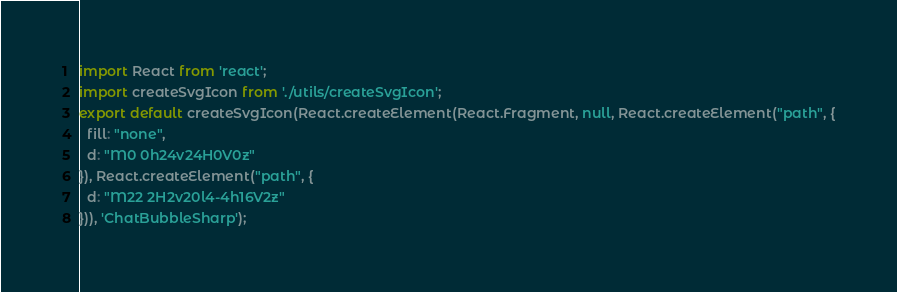<code> <loc_0><loc_0><loc_500><loc_500><_JavaScript_>import React from 'react';
import createSvgIcon from './utils/createSvgIcon';
export default createSvgIcon(React.createElement(React.Fragment, null, React.createElement("path", {
  fill: "none",
  d: "M0 0h24v24H0V0z"
}), React.createElement("path", {
  d: "M22 2H2v20l4-4h16V2z"
})), 'ChatBubbleSharp');</code> 